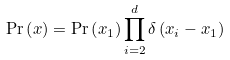Convert formula to latex. <formula><loc_0><loc_0><loc_500><loc_500>\Pr \left ( x \right ) = \Pr \left ( x _ { 1 } \right ) \prod _ { i = 2 } ^ { d } \delta \left ( x _ { i } - x _ { 1 } \right )</formula> 